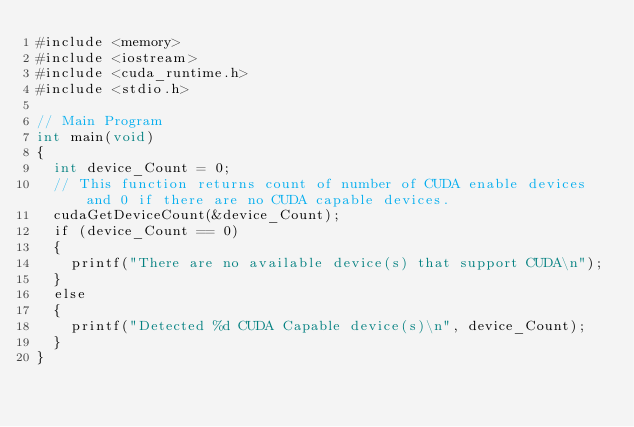Convert code to text. <code><loc_0><loc_0><loc_500><loc_500><_Cuda_>#include <memory>
#include <iostream>
#include <cuda_runtime.h>
#include <stdio.h>

// Main Program 
int main(void)
{
	int device_Count = 0;
	// This function returns count of number of CUDA enable devices and 0 if there are no CUDA capable devices.
	cudaGetDeviceCount(&device_Count);
	if (device_Count == 0)
	{
		printf("There are no available device(s) that support CUDA\n");
	}
	else
	{
		printf("Detected %d CUDA Capable device(s)\n", device_Count);
	}
}
</code> 